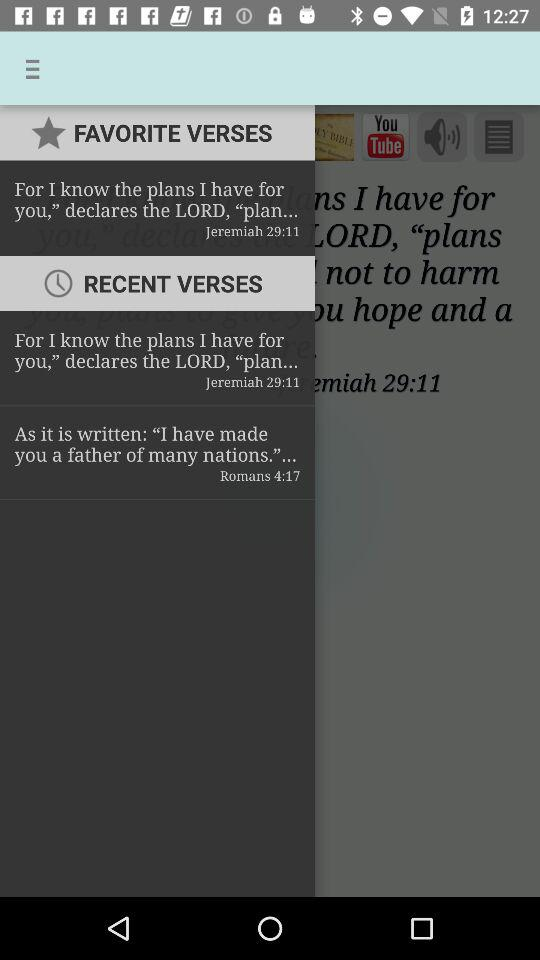How many more recent verses than favorite verses are there?
Answer the question using a single word or phrase. 1 